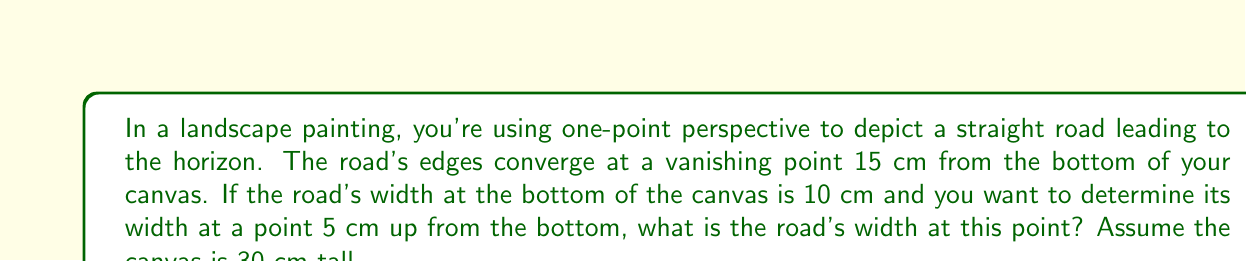Give your solution to this math problem. Let's approach this step-by-step:

1) In one-point perspective, we can use similar triangles to solve this problem.

2) Let's define our variables:
   $h$ = height of vanishing point from bottom = 15 cm
   $w_0$ = width of road at bottom = 10 cm
   $y$ = distance up from bottom where we want to find width = 5 cm
   $w$ = width we're trying to find

3) We can set up the following proportion based on similar triangles:

   $$\frac{w_0 - w}{w_0} = \frac{y}{h}$$

4) Substituting our known values:

   $$\frac{10 - w}{10} = \frac{5}{15}$$

5) Simplify the right side:

   $$\frac{10 - w}{10} = \frac{1}{3}$$

6) Multiply both sides by 10:

   $$10 - w = \frac{10}{3}$$

7) Subtract both sides from 10:

   $$w = 10 - \frac{10}{3} = \frac{30}{3} - \frac{10}{3} = \frac{20}{3}$$

8) Simplify:

   $$w = \frac{20}{3} \approx 6.67 \text{ cm}$$

Thus, the width of the road at 5 cm up from the bottom of the canvas is approximately 6.67 cm.
Answer: $\frac{20}{3}$ cm or approximately 6.67 cm 